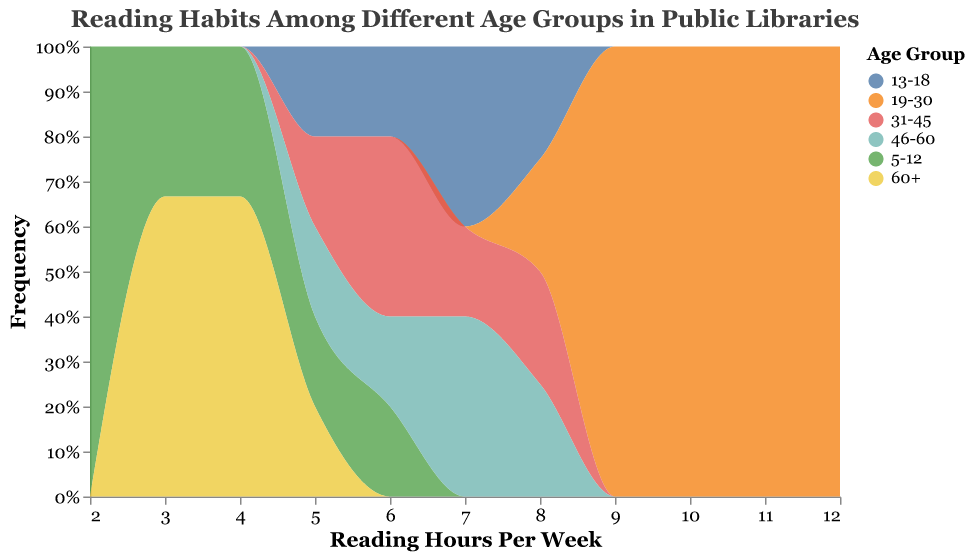What is the title of the figure? The title is clearly labeled at the top of the figure as "Reading Habits Among Different Age Groups in Public Libraries."
Answer: Reading Habits Among Different Age Groups in Public Libraries Which age group spends the most average hours reading per week? Observe the shape and peak of each age group's distribution along the x-axis. The distribution for the "19-30" age group peaks at the higher end (9-12 hours per week) compared to other groups.
Answer: 19-30 What is the most frequently observed reading hours per week for the 13-18 age group? Look at the density heights along the x-axis for the "13-18" age group (marked by its unique color). The distribution peak is at 7 hours per week.
Answer: 7 How many different age groups are represented in the chart? Each unique color in the legend represents a different age group. Count the entries in the legend.
Answer: 6 Which age group has the widest spread in reading hours per week? Compare the x-axis span of each age group's distribution. The "19-30" age group spans from 8 to 12 hours per week, indicating the widest spread.
Answer: 19-30 What is the frequency axis labeled on the chart? The y-axis represents the "Frequency" of reading hours per week and is labeled accordingly.
Answer: Frequency Compare the reading hours between the 5-12 and 46-60 age groups. Which group has individuals reading more on average? The "46-60" age group has a distribution extending to higher reading hours (5-8) compared to the "5-12" group (2-6).
Answer: 46-60 Do any age groups have overlapping reading habits? Yes, the reading distributions of "31-45" and "46-60" overlap significantly, showing similar distributions with peaks around 6-7 hours per week.
Answer: Yes What's the highest frequency of reading hours per week for the 60+ age group? The "60+" group's distribution peaks at 3 and 4 hours per week, showing these are the most frequent reading hours for this age group.
Answer: 3 and 4 What's the average reading hours per week for those aged 31-45? Average is calculated by summing their reading hours (5+6+6+7+8 = 32) and dividing by the number of observations (5). The average is 32/5.
Answer: 6.4 